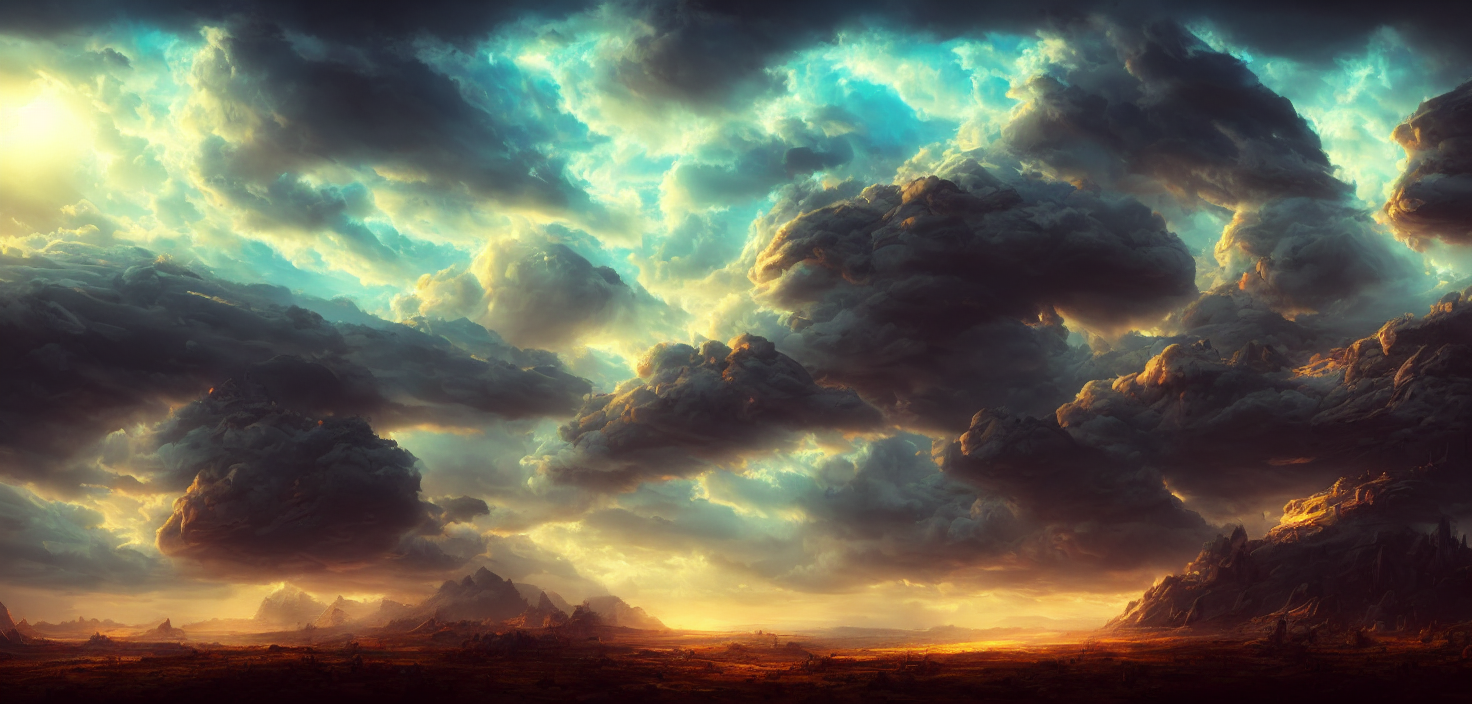What is the lighting like in the image?
A. Overly bright with harsh lighting.
B. Dimly lit with poor visibility.
C. Sufficient.
D. Underlit with strong shadows.
Answer with the option's letter from the given choices directly.
 C. 